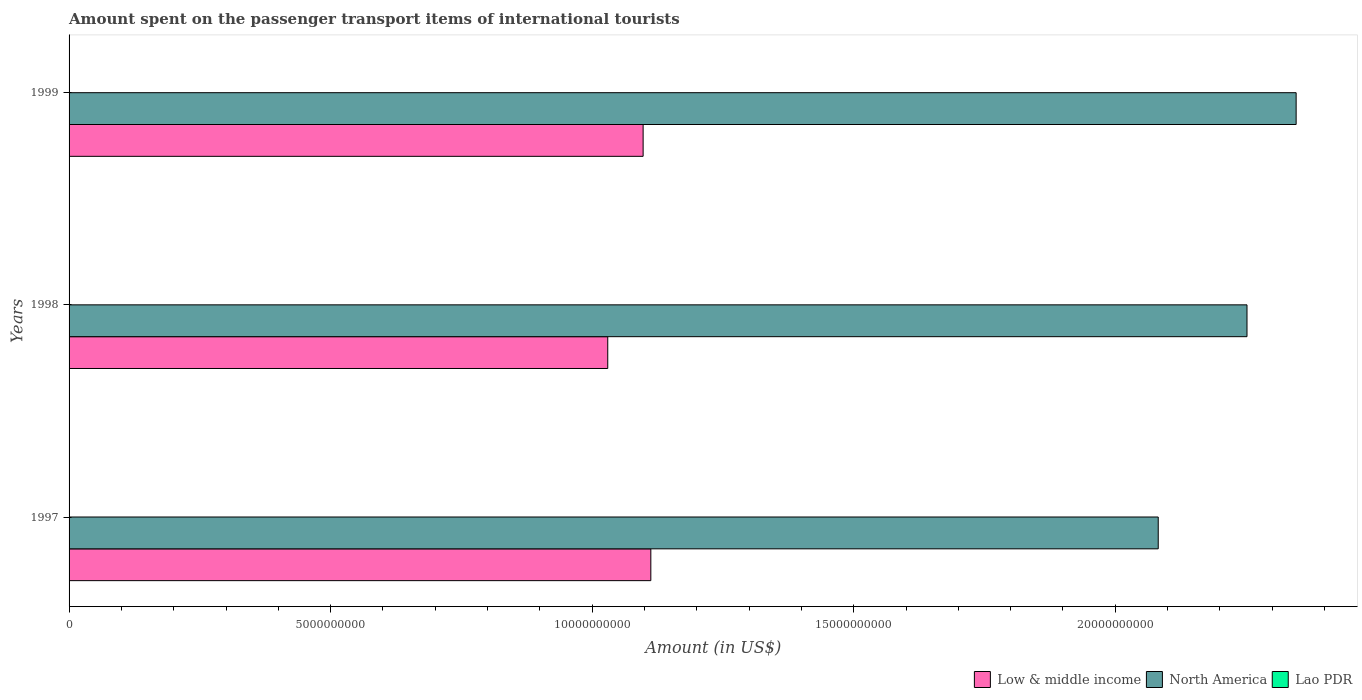How many different coloured bars are there?
Keep it short and to the point. 3. Are the number of bars per tick equal to the number of legend labels?
Your response must be concise. Yes. How many bars are there on the 3rd tick from the top?
Offer a very short reply. 3. What is the amount spent on the passenger transport items of international tourists in Low & middle income in 1998?
Your response must be concise. 1.03e+1. Across all years, what is the minimum amount spent on the passenger transport items of international tourists in North America?
Make the answer very short. 2.08e+1. In which year was the amount spent on the passenger transport items of international tourists in Lao PDR minimum?
Your answer should be compact. 1999. What is the total amount spent on the passenger transport items of international tourists in Low & middle income in the graph?
Provide a succinct answer. 3.24e+1. What is the difference between the amount spent on the passenger transport items of international tourists in Lao PDR in 1998 and that in 1999?
Your answer should be very brief. 1.00e+06. What is the difference between the amount spent on the passenger transport items of international tourists in Lao PDR in 1998 and the amount spent on the passenger transport items of international tourists in Low & middle income in 1999?
Your answer should be compact. -1.10e+1. What is the average amount spent on the passenger transport items of international tourists in Lao PDR per year?
Your response must be concise. 5.67e+06. In the year 1999, what is the difference between the amount spent on the passenger transport items of international tourists in North America and amount spent on the passenger transport items of international tourists in Low & middle income?
Keep it short and to the point. 1.25e+1. In how many years, is the amount spent on the passenger transport items of international tourists in Lao PDR greater than 14000000000 US$?
Provide a succinct answer. 0. What is the ratio of the amount spent on the passenger transport items of international tourists in Low & middle income in 1997 to that in 1999?
Ensure brevity in your answer.  1.01. Is the amount spent on the passenger transport items of international tourists in Low & middle income in 1997 less than that in 1998?
Give a very brief answer. No. Is the difference between the amount spent on the passenger transport items of international tourists in North America in 1998 and 1999 greater than the difference between the amount spent on the passenger transport items of international tourists in Low & middle income in 1998 and 1999?
Keep it short and to the point. No. What is the difference between the highest and the second highest amount spent on the passenger transport items of international tourists in Low & middle income?
Provide a succinct answer. 1.47e+08. In how many years, is the amount spent on the passenger transport items of international tourists in Lao PDR greater than the average amount spent on the passenger transport items of international tourists in Lao PDR taken over all years?
Give a very brief answer. 2. Is the sum of the amount spent on the passenger transport items of international tourists in North America in 1998 and 1999 greater than the maximum amount spent on the passenger transport items of international tourists in Lao PDR across all years?
Offer a very short reply. Yes. What does the 2nd bar from the bottom in 1999 represents?
Provide a short and direct response. North America. Is it the case that in every year, the sum of the amount spent on the passenger transport items of international tourists in Lao PDR and amount spent on the passenger transport items of international tourists in North America is greater than the amount spent on the passenger transport items of international tourists in Low & middle income?
Give a very brief answer. Yes. How many bars are there?
Offer a very short reply. 9. How many years are there in the graph?
Keep it short and to the point. 3. Are the values on the major ticks of X-axis written in scientific E-notation?
Provide a short and direct response. No. Does the graph contain any zero values?
Provide a short and direct response. No. Does the graph contain grids?
Make the answer very short. No. Where does the legend appear in the graph?
Give a very brief answer. Bottom right. How are the legend labels stacked?
Give a very brief answer. Horizontal. What is the title of the graph?
Your response must be concise. Amount spent on the passenger transport items of international tourists. Does "Antigua and Barbuda" appear as one of the legend labels in the graph?
Your response must be concise. No. What is the label or title of the X-axis?
Give a very brief answer. Amount (in US$). What is the Amount (in US$) in Low & middle income in 1997?
Keep it short and to the point. 1.11e+1. What is the Amount (in US$) of North America in 1997?
Ensure brevity in your answer.  2.08e+1. What is the Amount (in US$) of Low & middle income in 1998?
Offer a terse response. 1.03e+1. What is the Amount (in US$) in North America in 1998?
Provide a short and direct response. 2.25e+1. What is the Amount (in US$) in Low & middle income in 1999?
Provide a succinct answer. 1.10e+1. What is the Amount (in US$) in North America in 1999?
Keep it short and to the point. 2.35e+1. Across all years, what is the maximum Amount (in US$) in Low & middle income?
Give a very brief answer. 1.11e+1. Across all years, what is the maximum Amount (in US$) in North America?
Make the answer very short. 2.35e+1. Across all years, what is the maximum Amount (in US$) of Lao PDR?
Provide a succinct answer. 6.00e+06. Across all years, what is the minimum Amount (in US$) of Low & middle income?
Your answer should be compact. 1.03e+1. Across all years, what is the minimum Amount (in US$) in North America?
Give a very brief answer. 2.08e+1. Across all years, what is the minimum Amount (in US$) in Lao PDR?
Make the answer very short. 5.00e+06. What is the total Amount (in US$) of Low & middle income in the graph?
Make the answer very short. 3.24e+1. What is the total Amount (in US$) of North America in the graph?
Keep it short and to the point. 6.68e+1. What is the total Amount (in US$) of Lao PDR in the graph?
Your answer should be compact. 1.70e+07. What is the difference between the Amount (in US$) of Low & middle income in 1997 and that in 1998?
Offer a terse response. 8.24e+08. What is the difference between the Amount (in US$) in North America in 1997 and that in 1998?
Your response must be concise. -1.70e+09. What is the difference between the Amount (in US$) of Low & middle income in 1997 and that in 1999?
Ensure brevity in your answer.  1.47e+08. What is the difference between the Amount (in US$) in North America in 1997 and that in 1999?
Provide a short and direct response. -2.64e+09. What is the difference between the Amount (in US$) of Lao PDR in 1997 and that in 1999?
Make the answer very short. 1.00e+06. What is the difference between the Amount (in US$) of Low & middle income in 1998 and that in 1999?
Offer a very short reply. -6.76e+08. What is the difference between the Amount (in US$) of North America in 1998 and that in 1999?
Keep it short and to the point. -9.39e+08. What is the difference between the Amount (in US$) of Low & middle income in 1997 and the Amount (in US$) of North America in 1998?
Ensure brevity in your answer.  -1.14e+1. What is the difference between the Amount (in US$) of Low & middle income in 1997 and the Amount (in US$) of Lao PDR in 1998?
Offer a very short reply. 1.11e+1. What is the difference between the Amount (in US$) of North America in 1997 and the Amount (in US$) of Lao PDR in 1998?
Your response must be concise. 2.08e+1. What is the difference between the Amount (in US$) in Low & middle income in 1997 and the Amount (in US$) in North America in 1999?
Keep it short and to the point. -1.23e+1. What is the difference between the Amount (in US$) of Low & middle income in 1997 and the Amount (in US$) of Lao PDR in 1999?
Provide a short and direct response. 1.11e+1. What is the difference between the Amount (in US$) of North America in 1997 and the Amount (in US$) of Lao PDR in 1999?
Your answer should be very brief. 2.08e+1. What is the difference between the Amount (in US$) of Low & middle income in 1998 and the Amount (in US$) of North America in 1999?
Keep it short and to the point. -1.32e+1. What is the difference between the Amount (in US$) in Low & middle income in 1998 and the Amount (in US$) in Lao PDR in 1999?
Your answer should be compact. 1.03e+1. What is the difference between the Amount (in US$) of North America in 1998 and the Amount (in US$) of Lao PDR in 1999?
Ensure brevity in your answer.  2.25e+1. What is the average Amount (in US$) of Low & middle income per year?
Your answer should be very brief. 1.08e+1. What is the average Amount (in US$) of North America per year?
Make the answer very short. 2.23e+1. What is the average Amount (in US$) of Lao PDR per year?
Provide a short and direct response. 5.67e+06. In the year 1997, what is the difference between the Amount (in US$) in Low & middle income and Amount (in US$) in North America?
Provide a short and direct response. -9.70e+09. In the year 1997, what is the difference between the Amount (in US$) of Low & middle income and Amount (in US$) of Lao PDR?
Provide a succinct answer. 1.11e+1. In the year 1997, what is the difference between the Amount (in US$) of North America and Amount (in US$) of Lao PDR?
Keep it short and to the point. 2.08e+1. In the year 1998, what is the difference between the Amount (in US$) of Low & middle income and Amount (in US$) of North America?
Keep it short and to the point. -1.22e+1. In the year 1998, what is the difference between the Amount (in US$) of Low & middle income and Amount (in US$) of Lao PDR?
Offer a terse response. 1.03e+1. In the year 1998, what is the difference between the Amount (in US$) of North America and Amount (in US$) of Lao PDR?
Your answer should be compact. 2.25e+1. In the year 1999, what is the difference between the Amount (in US$) in Low & middle income and Amount (in US$) in North America?
Provide a succinct answer. -1.25e+1. In the year 1999, what is the difference between the Amount (in US$) in Low & middle income and Amount (in US$) in Lao PDR?
Your answer should be very brief. 1.10e+1. In the year 1999, what is the difference between the Amount (in US$) in North America and Amount (in US$) in Lao PDR?
Your response must be concise. 2.35e+1. What is the ratio of the Amount (in US$) of North America in 1997 to that in 1998?
Your response must be concise. 0.92. What is the ratio of the Amount (in US$) in Low & middle income in 1997 to that in 1999?
Provide a succinct answer. 1.01. What is the ratio of the Amount (in US$) in North America in 1997 to that in 1999?
Ensure brevity in your answer.  0.89. What is the ratio of the Amount (in US$) of Low & middle income in 1998 to that in 1999?
Make the answer very short. 0.94. What is the ratio of the Amount (in US$) of North America in 1998 to that in 1999?
Your answer should be compact. 0.96. What is the ratio of the Amount (in US$) of Lao PDR in 1998 to that in 1999?
Give a very brief answer. 1.2. What is the difference between the highest and the second highest Amount (in US$) of Low & middle income?
Ensure brevity in your answer.  1.47e+08. What is the difference between the highest and the second highest Amount (in US$) of North America?
Offer a terse response. 9.39e+08. What is the difference between the highest and the second highest Amount (in US$) of Lao PDR?
Make the answer very short. 0. What is the difference between the highest and the lowest Amount (in US$) of Low & middle income?
Your answer should be very brief. 8.24e+08. What is the difference between the highest and the lowest Amount (in US$) of North America?
Provide a succinct answer. 2.64e+09. 